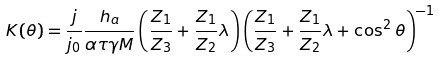Convert formula to latex. <formula><loc_0><loc_0><loc_500><loc_500>K ( \theta ) = \frac { j } { j _ { 0 } } \frac { h _ { a } } { \alpha \tau \gamma M } \left ( \frac { Z _ { 1 } } { Z _ { 3 } } + \frac { Z _ { 1 } } { Z _ { 2 } } \lambda \right ) \left ( \frac { Z _ { 1 } } { Z _ { 3 } } + \frac { Z _ { 1 } } { Z _ { 2 } } \lambda + \cos ^ { 2 } \theta \right ) ^ { - 1 }</formula> 